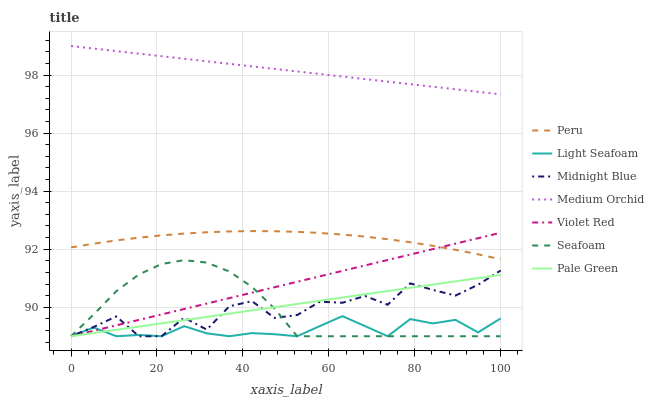Does Midnight Blue have the minimum area under the curve?
Answer yes or no. No. Does Midnight Blue have the maximum area under the curve?
Answer yes or no. No. Is Medium Orchid the smoothest?
Answer yes or no. No. Is Medium Orchid the roughest?
Answer yes or no. No. Does Medium Orchid have the lowest value?
Answer yes or no. No. Does Midnight Blue have the highest value?
Answer yes or no. No. Is Violet Red less than Medium Orchid?
Answer yes or no. Yes. Is Peru greater than Seafoam?
Answer yes or no. Yes. Does Violet Red intersect Medium Orchid?
Answer yes or no. No. 